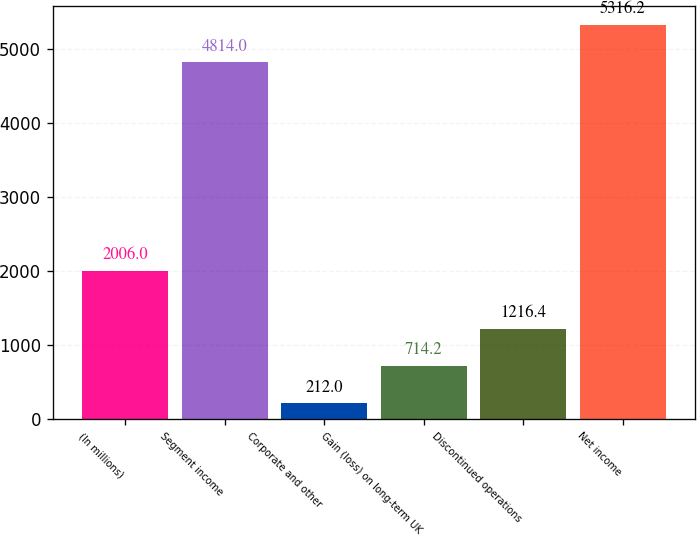<chart> <loc_0><loc_0><loc_500><loc_500><bar_chart><fcel>(In millions)<fcel>Segment income<fcel>Corporate and other<fcel>Gain (loss) on long-term UK<fcel>Discontinued operations<fcel>Net income<nl><fcel>2006<fcel>4814<fcel>212<fcel>714.2<fcel>1216.4<fcel>5316.2<nl></chart> 